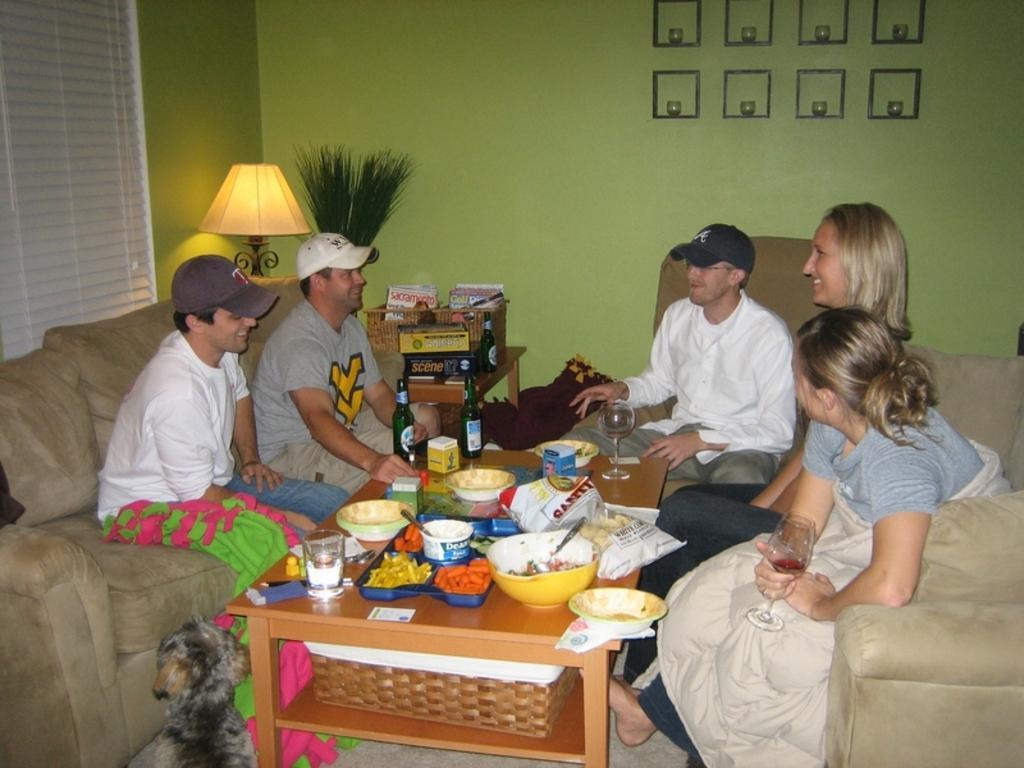How would you summarize this image in a sentence or two? A family members are sitting around table. Of them three are men and two are women. There are some eatables in bowls on the table. There are some glasses,wine bottles and food packets on the table. There is a lamp beside the sofa. 